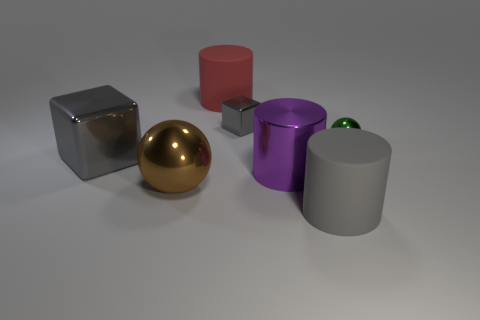There is a brown object that is the same size as the gray rubber thing; what is its shape?
Provide a succinct answer. Sphere. Are there any large objects of the same color as the large metallic cube?
Your answer should be very brief. Yes. Are there an equal number of metal blocks that are right of the big shiny ball and small red cubes?
Provide a short and direct response. No. Does the small shiny block have the same color as the metal cylinder?
Make the answer very short. No. How big is the thing that is in front of the big purple metallic cylinder and right of the brown metallic sphere?
Provide a succinct answer. Large. There is a sphere that is the same material as the tiny green thing; what is its color?
Your response must be concise. Brown. How many big purple things have the same material as the tiny block?
Keep it short and to the point. 1. Are there an equal number of purple shiny things that are to the left of the brown thing and metal cylinders right of the large red rubber thing?
Your answer should be very brief. No. There is a big purple object; is it the same shape as the small object that is on the right side of the big gray rubber thing?
Ensure brevity in your answer.  No. There is a large thing that is the same color as the big cube; what is its material?
Your answer should be compact. Rubber. 